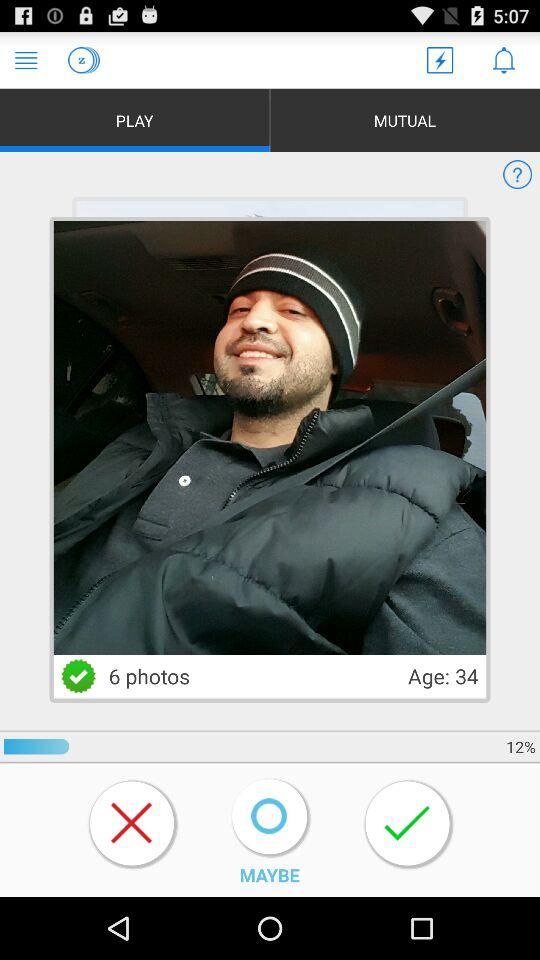What is the gender of the user?
When the provided information is insufficient, respond with <no answer>. <no answer> 